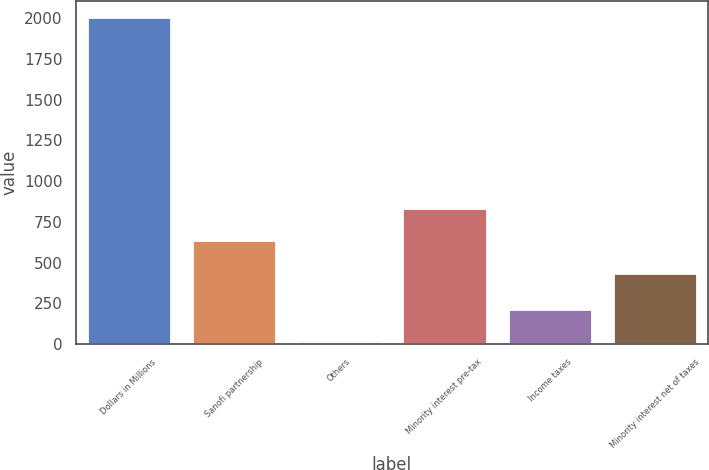<chart> <loc_0><loc_0><loc_500><loc_500><bar_chart><fcel>Dollars in Millions<fcel>Sanofi partnership<fcel>Others<fcel>Minority interest pre-tax<fcel>Income taxes<fcel>Minority interest net of taxes<nl><fcel>2006<fcel>638.7<fcel>19<fcel>837.4<fcel>217.7<fcel>440<nl></chart> 